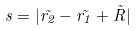<formula> <loc_0><loc_0><loc_500><loc_500>s = | \vec { r _ { 2 } } - \vec { r _ { 1 } } + \vec { R } |</formula> 